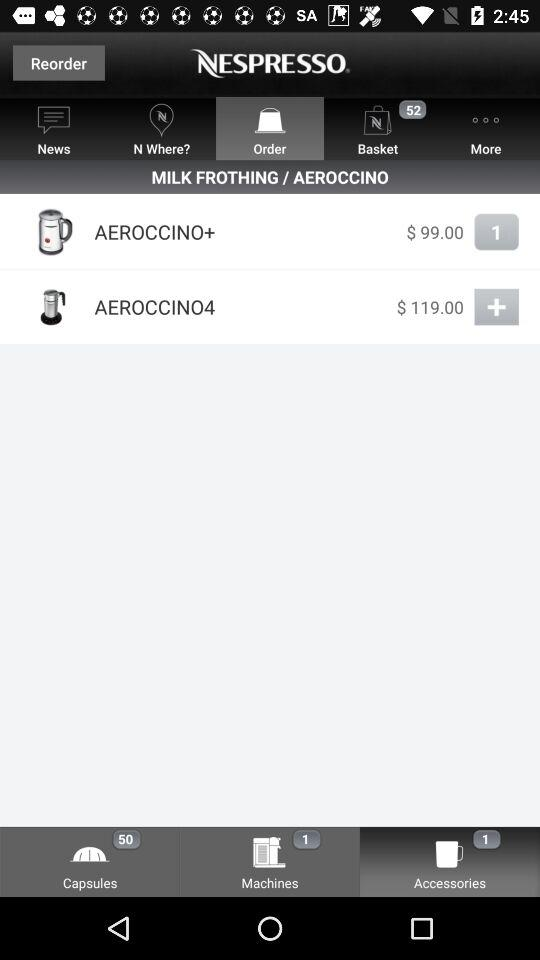What is the quantity of Aeroccino+? The quantity of Aeroccino+ is 1. 